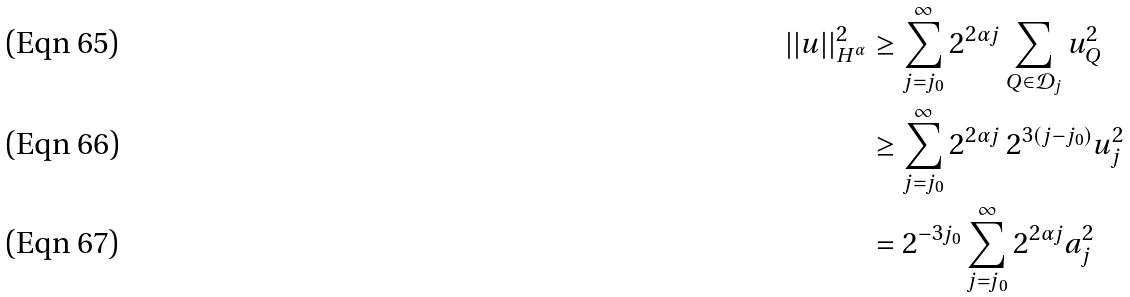Convert formula to latex. <formula><loc_0><loc_0><loc_500><loc_500>| | u | | ^ { 2 } _ { H ^ { \alpha } } & \geq \sum _ { j = j _ { 0 } } ^ { \infty } 2 ^ { 2 \alpha j } \sum _ { Q \in { \mathcal { D } _ { j } } } u ^ { 2 } _ { Q } \\ & \geq \sum _ { j = j _ { 0 } } ^ { \infty } 2 ^ { 2 \alpha j } \, 2 ^ { 3 ( j - j _ { 0 } ) } u ^ { 2 } _ { j } \\ & = 2 ^ { - 3 j _ { 0 } } \sum _ { j = j _ { 0 } } ^ { \infty } 2 ^ { 2 \alpha j } a _ { j } ^ { 2 }</formula> 